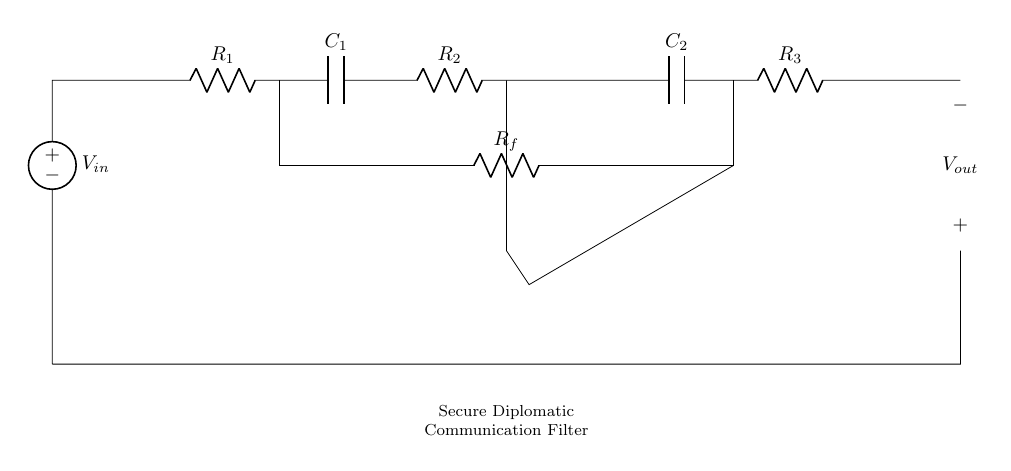What is the input voltage source in the circuit? The input voltage source is labeled as V_in, indicating the point where the voltage supply is connected.
Answer: V_in What type of components are used in this circuit? The circuit consists of resistors, capacitors, and an operational amplifier, as shown by the labels R and C for the resistors and capacitors, respectively.
Answer: Resistors, capacitors, operational amplifier How many resistors are present in this circuit? There are three resistors identified in the diagram, which are labeled R_1, R_2, and R_3.
Answer: Three What is the purpose of the operational amplifier in this circuit? The operational amplifier is used for signal amplification, enhancing the analog signal to ensure better communication.
Answer: Signal amplification What is the configuration type of this filter circuit? This is an analog filter circuit designed for secure communications, implying a low-pass or band-pass configuration, considering the capacitors and resistors work in conjunction to filter noise.
Answer: Filter circuit What is the role of capacitor C_1? The role of capacitor C_1 is to block high-frequency signals, allowing only lower-frequency components to pass through and thus filtering the input signal.
Answer: Block high-frequency signals 